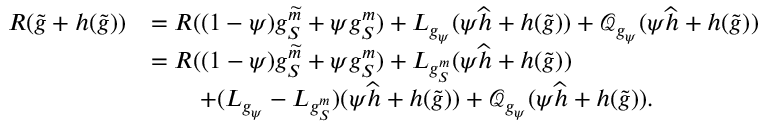Convert formula to latex. <formula><loc_0><loc_0><loc_500><loc_500>\begin{array} { r l } { R ( \widetilde { g } + h ( \widetilde { g } ) ) } & { = R ( ( 1 - \psi ) g _ { S } ^ { \widetilde { m } } + \psi g _ { S } ^ { m } ) + L _ { g _ { \psi } } ( \psi \widehat { h } + h ( \widetilde { g } ) ) + \mathcal { Q } _ { g _ { \psi } } ( \psi \widehat { h } + h ( \widetilde { g } ) ) } \\ & { = R ( ( 1 - \psi ) g _ { S } ^ { \widetilde { m } } + \psi g _ { S } ^ { m } ) + L _ { g _ { S } ^ { m } } ( \psi \widehat { h } + h ( \widetilde { g } ) ) } \\ & { \quad + ( L _ { g _ { \psi } } - L _ { g _ { S } ^ { m } } ) ( \psi \widehat { h } + h ( \widetilde { g } ) ) + \mathcal { Q } _ { g _ { \psi } } ( \psi \widehat { h } + h ( \widetilde { g } ) ) . } \end{array}</formula> 